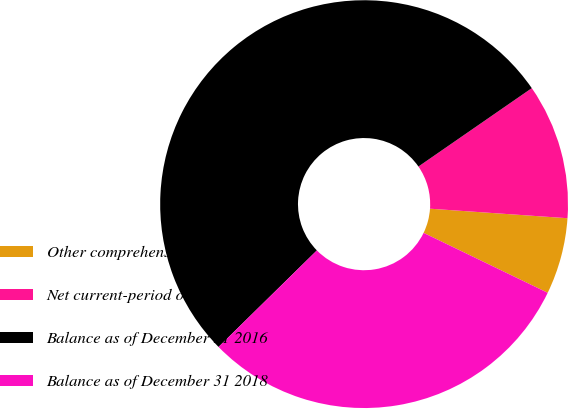Convert chart. <chart><loc_0><loc_0><loc_500><loc_500><pie_chart><fcel>Other comprehensive income<fcel>Net current-period other<fcel>Balance as of December 31 2016<fcel>Balance as of December 31 2018<nl><fcel>6.06%<fcel>10.73%<fcel>52.72%<fcel>30.49%<nl></chart> 